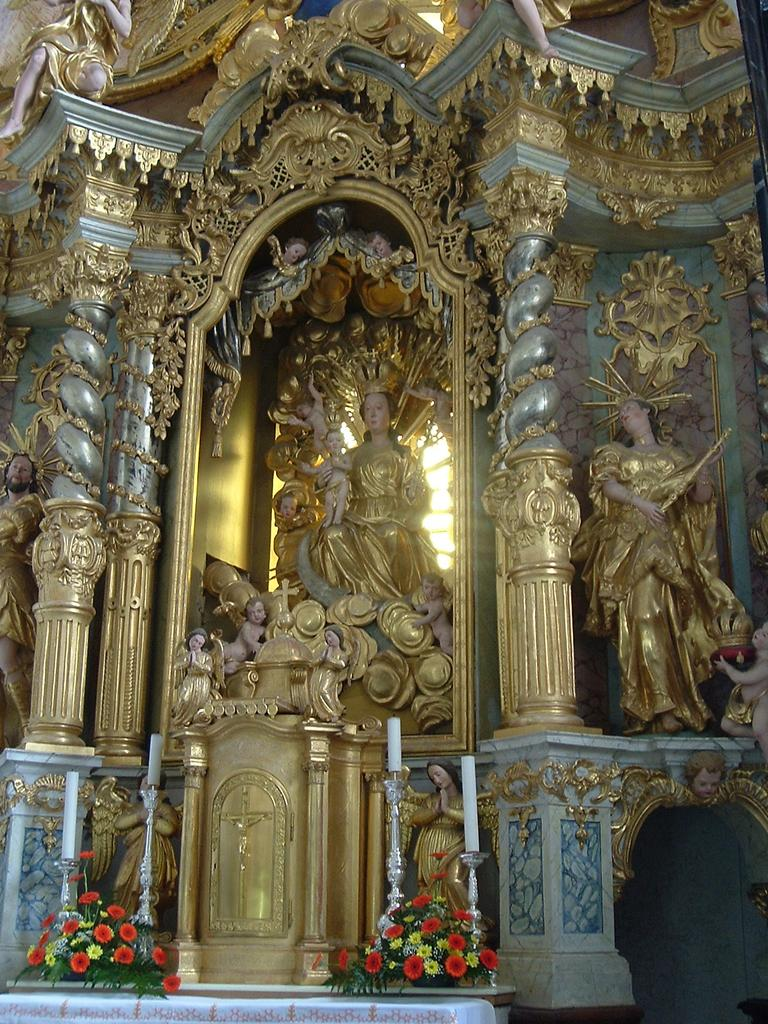What type of decorative items can be seen in the image? There are flower bouquets and candles in the image. What are the candles placed on in the image? There are candle stands in the image. Are there any other decorative objects in the image? Yes, there are sculptures in the image. What type of machine can be seen operating in the image? There is no machine present in the image; it features decorative items such as flower bouquets, candles, candle stands, and sculptures. 